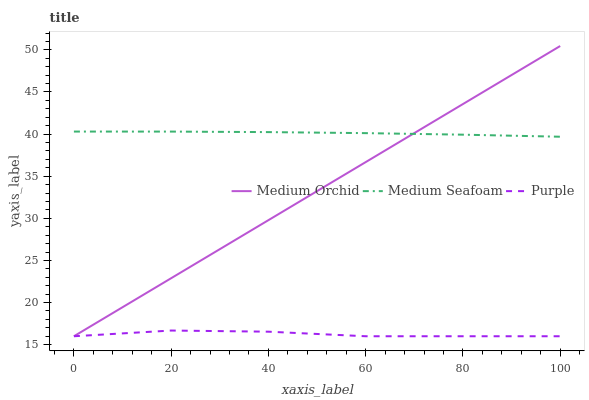Does Purple have the minimum area under the curve?
Answer yes or no. Yes. Does Medium Seafoam have the maximum area under the curve?
Answer yes or no. Yes. Does Medium Orchid have the minimum area under the curve?
Answer yes or no. No. Does Medium Orchid have the maximum area under the curve?
Answer yes or no. No. Is Medium Orchid the smoothest?
Answer yes or no. Yes. Is Purple the roughest?
Answer yes or no. Yes. Is Medium Seafoam the smoothest?
Answer yes or no. No. Is Medium Seafoam the roughest?
Answer yes or no. No. Does Purple have the lowest value?
Answer yes or no. Yes. Does Medium Seafoam have the lowest value?
Answer yes or no. No. Does Medium Orchid have the highest value?
Answer yes or no. Yes. Does Medium Seafoam have the highest value?
Answer yes or no. No. Is Purple less than Medium Seafoam?
Answer yes or no. Yes. Is Medium Seafoam greater than Purple?
Answer yes or no. Yes. Does Medium Seafoam intersect Medium Orchid?
Answer yes or no. Yes. Is Medium Seafoam less than Medium Orchid?
Answer yes or no. No. Is Medium Seafoam greater than Medium Orchid?
Answer yes or no. No. Does Purple intersect Medium Seafoam?
Answer yes or no. No. 